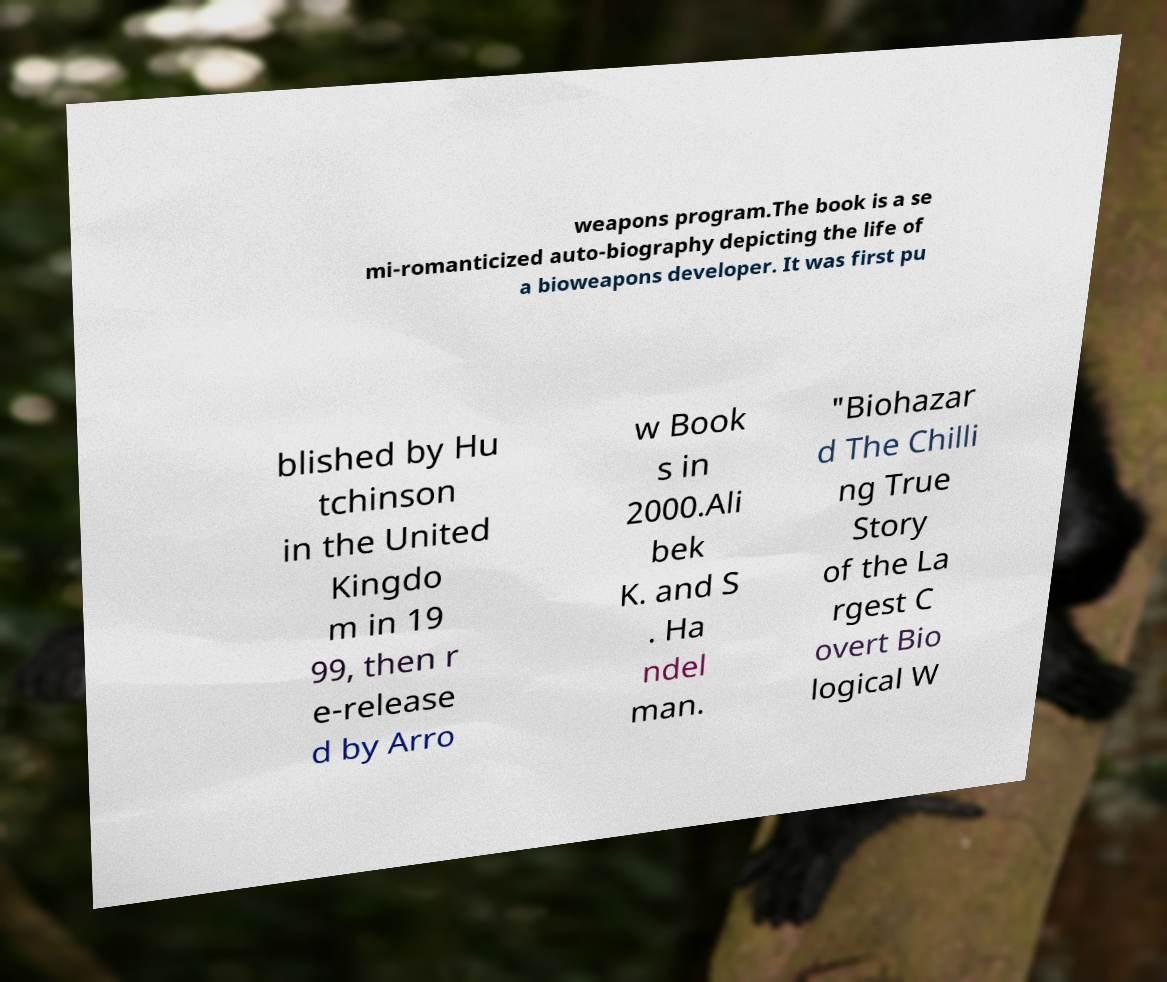Could you extract and type out the text from this image? weapons program.The book is a se mi-romanticized auto-biography depicting the life of a bioweapons developer. It was first pu blished by Hu tchinson in the United Kingdo m in 19 99, then r e-release d by Arro w Book s in 2000.Ali bek K. and S . Ha ndel man. "Biohazar d The Chilli ng True Story of the La rgest C overt Bio logical W 